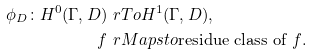<formula> <loc_0><loc_0><loc_500><loc_500>\phi _ { D } \colon H ^ { 0 } ( \Gamma , D ) & \ r T o H ^ { 1 } ( \Gamma , D ) , \\ f & \ r M a p s t o \text {residue class of $f$} .</formula> 